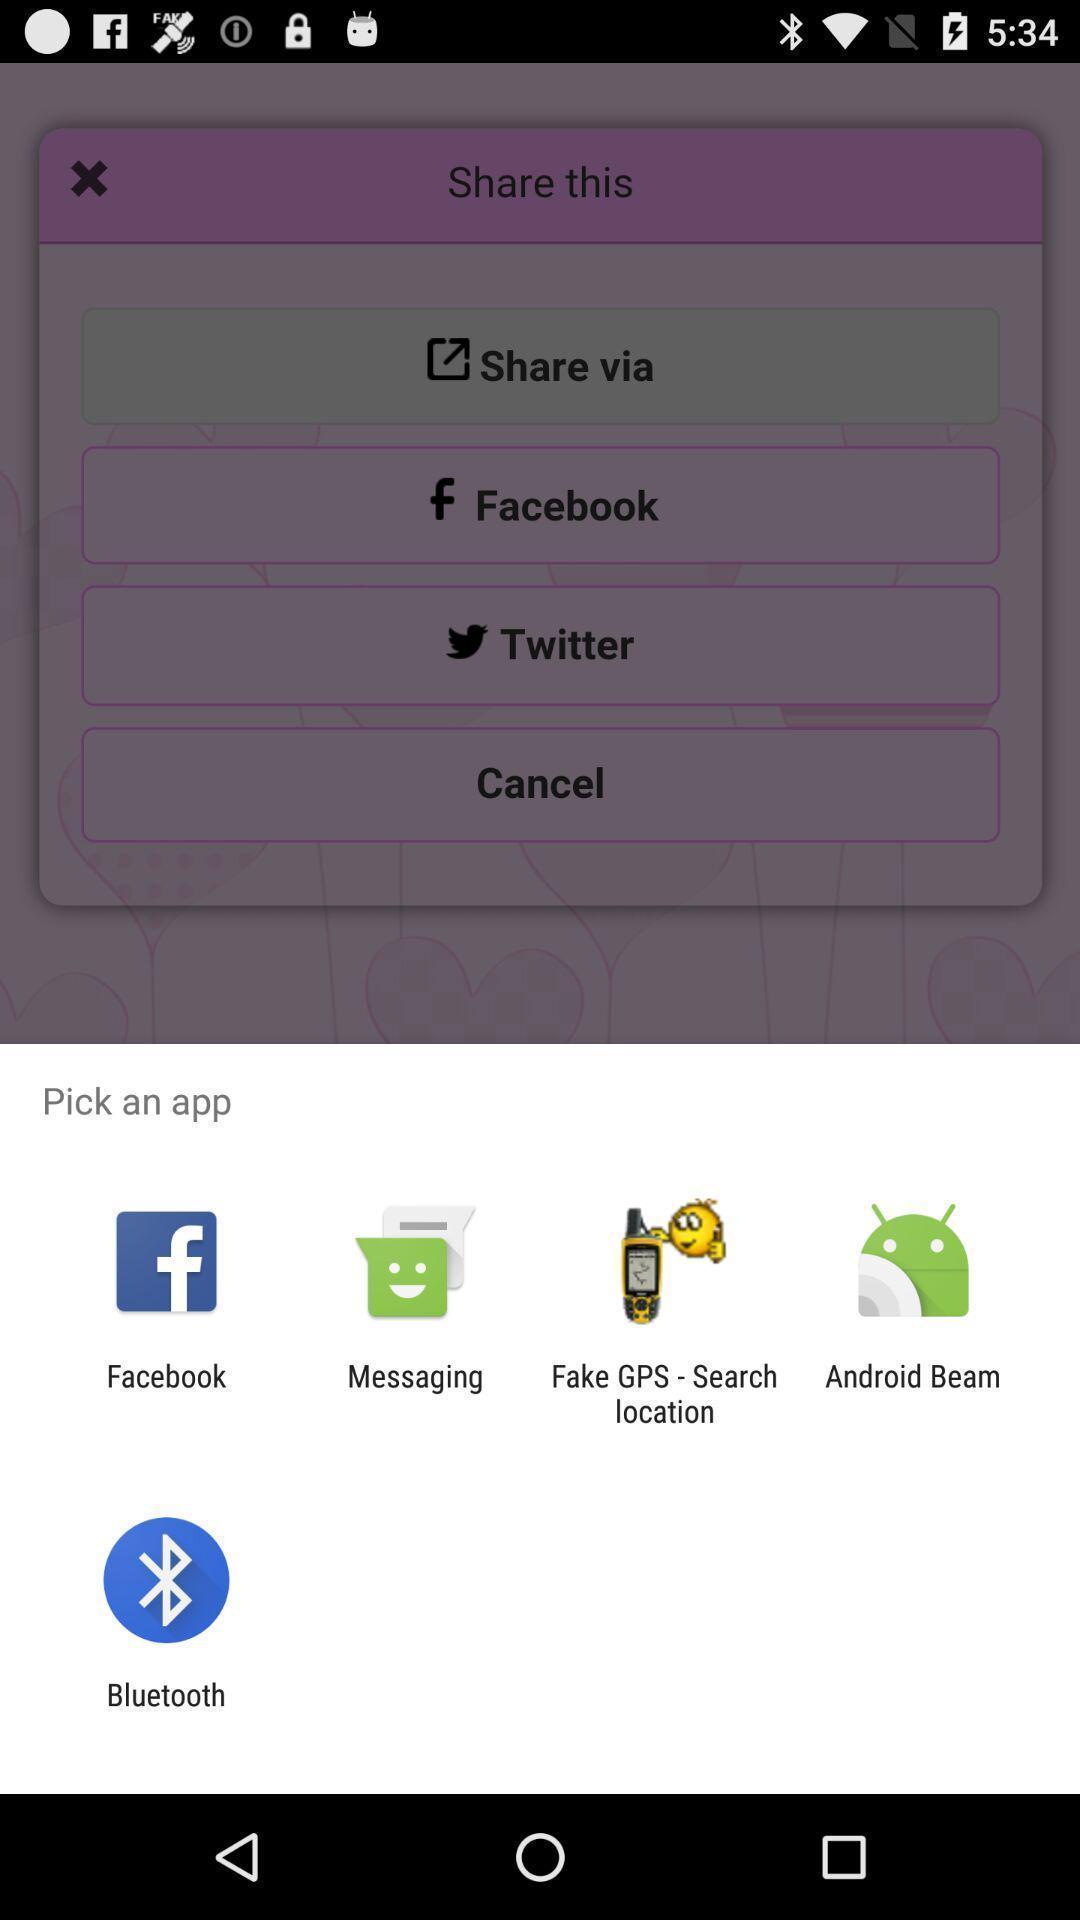Summarize the information in this screenshot. Popup displaying different apps to share quotes. 